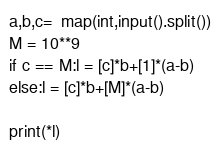<code> <loc_0><loc_0><loc_500><loc_500><_Python_>a,b,c=  map(int,input().split())
M = 10**9
if c == M:l = [c]*b+[1]*(a-b)
else:l = [c]*b+[M]*(a-b)

print(*l)</code> 